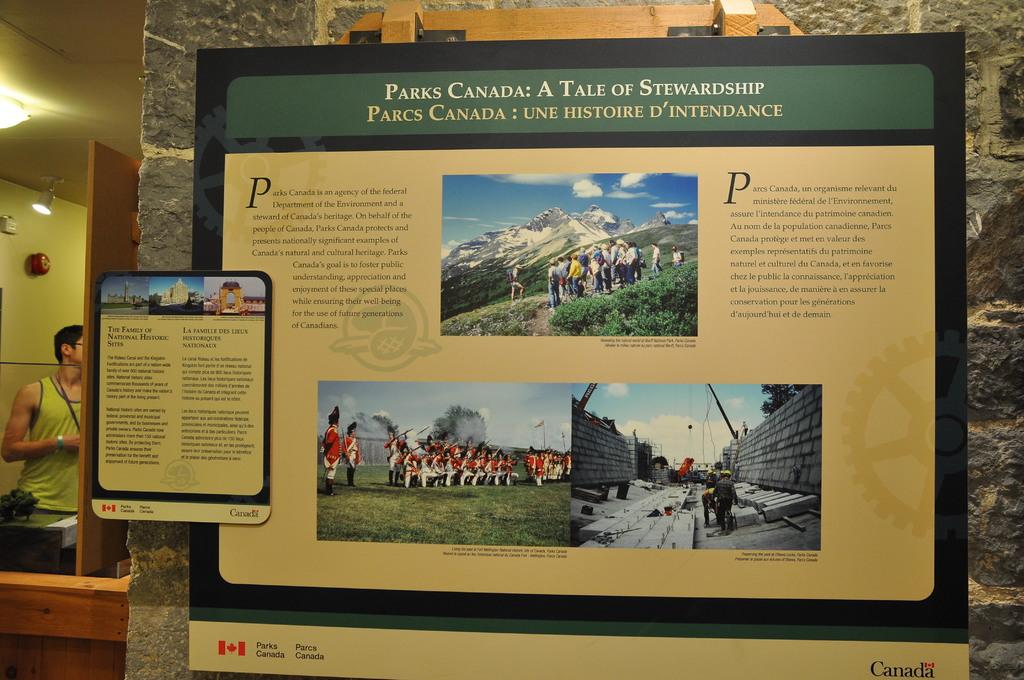Where is this park located?
Your answer should be compact. Canada. What phrase is written in french at the top of the sign?
Provide a short and direct response. Parks canada: a tale of stewardship. 